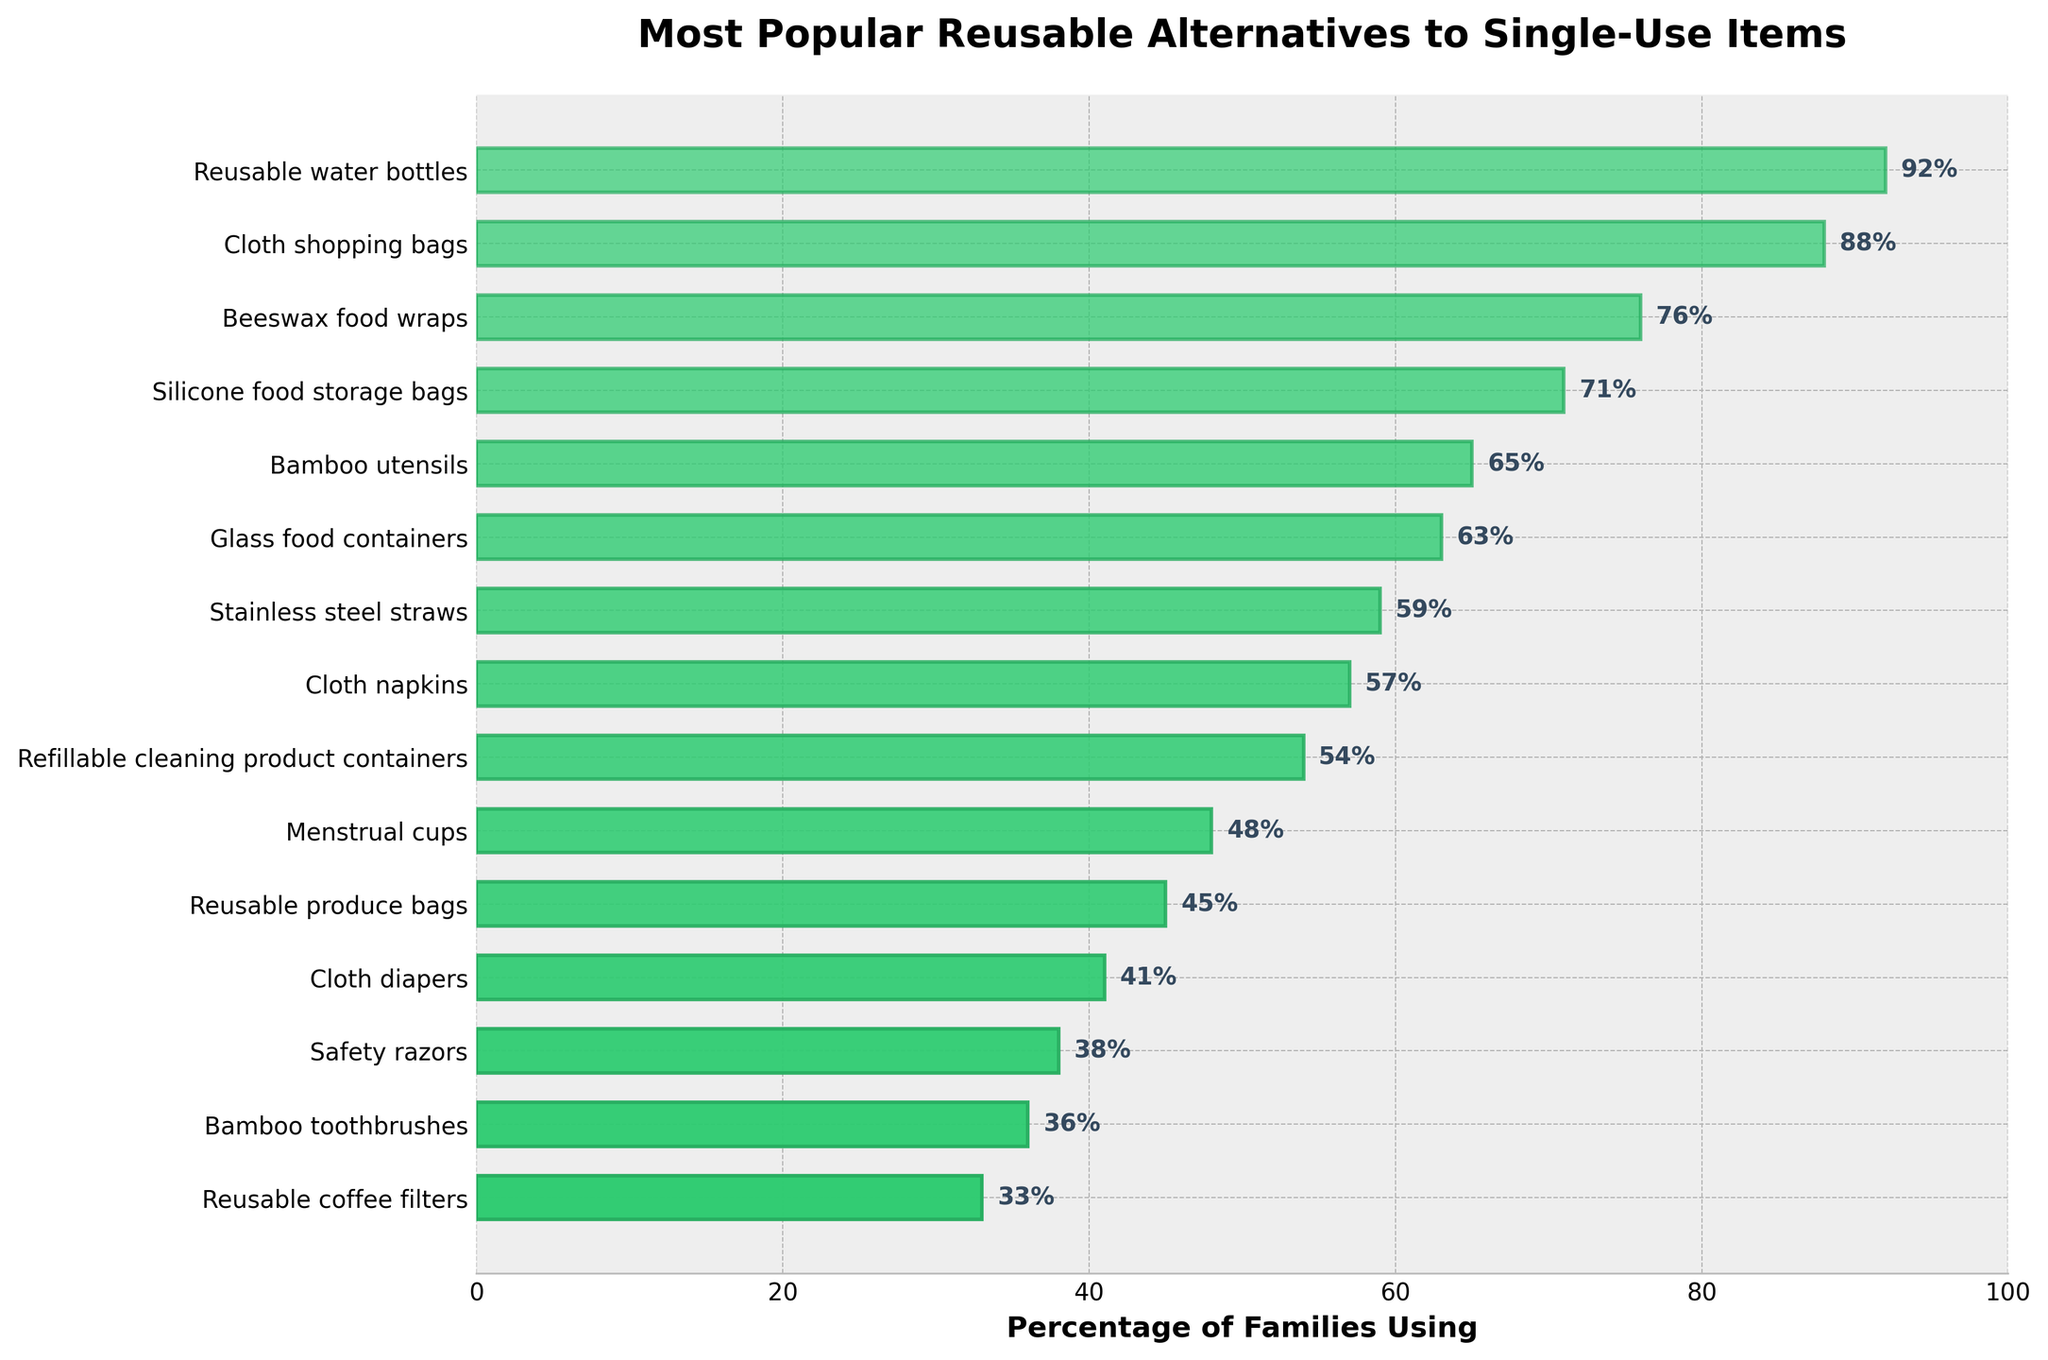What's the most popular reusable alternative to single-use items among environmentally conscious families? By looking at the bar chart, the bar for "Reusable water bottles" is the longest, indicating it has the highest percentage.
Answer: Reusable water bottles Which is more popular: cloth diapers or bamboo toothbrushes? By comparing the two bars, "Cloth diapers" has a higher percentage (41%) than "Bamboo toothbrushes" (36%).
Answer: Cloth diapers What is the cumulative percentage of families using either beeswax food wraps or silicone food storage bags? The percentage for beeswax food wraps is 76%, and for silicone food storage bags, it is 71%. Adding these together, 76% + 71% = 147%.
Answer: 147% Which reusable item has the smallest percentage of families using it, and what is that percentage? The shortest bar in the chart is for "Reusable coffee filters" at 33%.
Answer: Reusable coffee filters, 33% How many items have a usage percentage higher than 60%? The items with percentages higher than 60% are: Reusable water bottles, Cloth shopping bags, Beeswax food wraps, Silicone food storage bags, and Bamboo utensils. Counting these gives 5 items.
Answer: 5 What is the difference in percentage between families using reusable produce bags and families using cloth diapers? The percentage for reusable produce bags is 45%, and for cloth diapers, it is 41%. Subtracting these, 45% - 41% = 4%.
Answer: 4% Which items have usage percentages that are within 5% of each other? Cloth diapers (41%) and reusable produce bags (45%) are within 5%. Bamboo toothbrushes (36%) and Safety razors (38%) are within 5% of each other.
Answer: Cloth diapers and reusable produce bags, Bamboo toothbrushes and safety razors What's the average percentage of families using the top 3 most popular reusable items? The top 3 items are Reusable water bottles (92%), Cloth shopping bags (88%), and Beeswax food wraps (76%). The average is (92+88+76)/3 = 85.33%.
Answer: 85.33% Between stainless steel straws and refillable cleaning product containers, which one is used by more families and by what difference? Stainless steel straws have 59% usage, and refillable cleaning product containers have 54% usage. The difference is 59% - 54% = 5%.
Answer: Stainless steel straws, 5% Which item's bar has the highest opacity? The bar for "Reusable water bottles" is the most opaque because it's at the top of the chart where the opacity is highest.
Answer: Reusable water bottles 